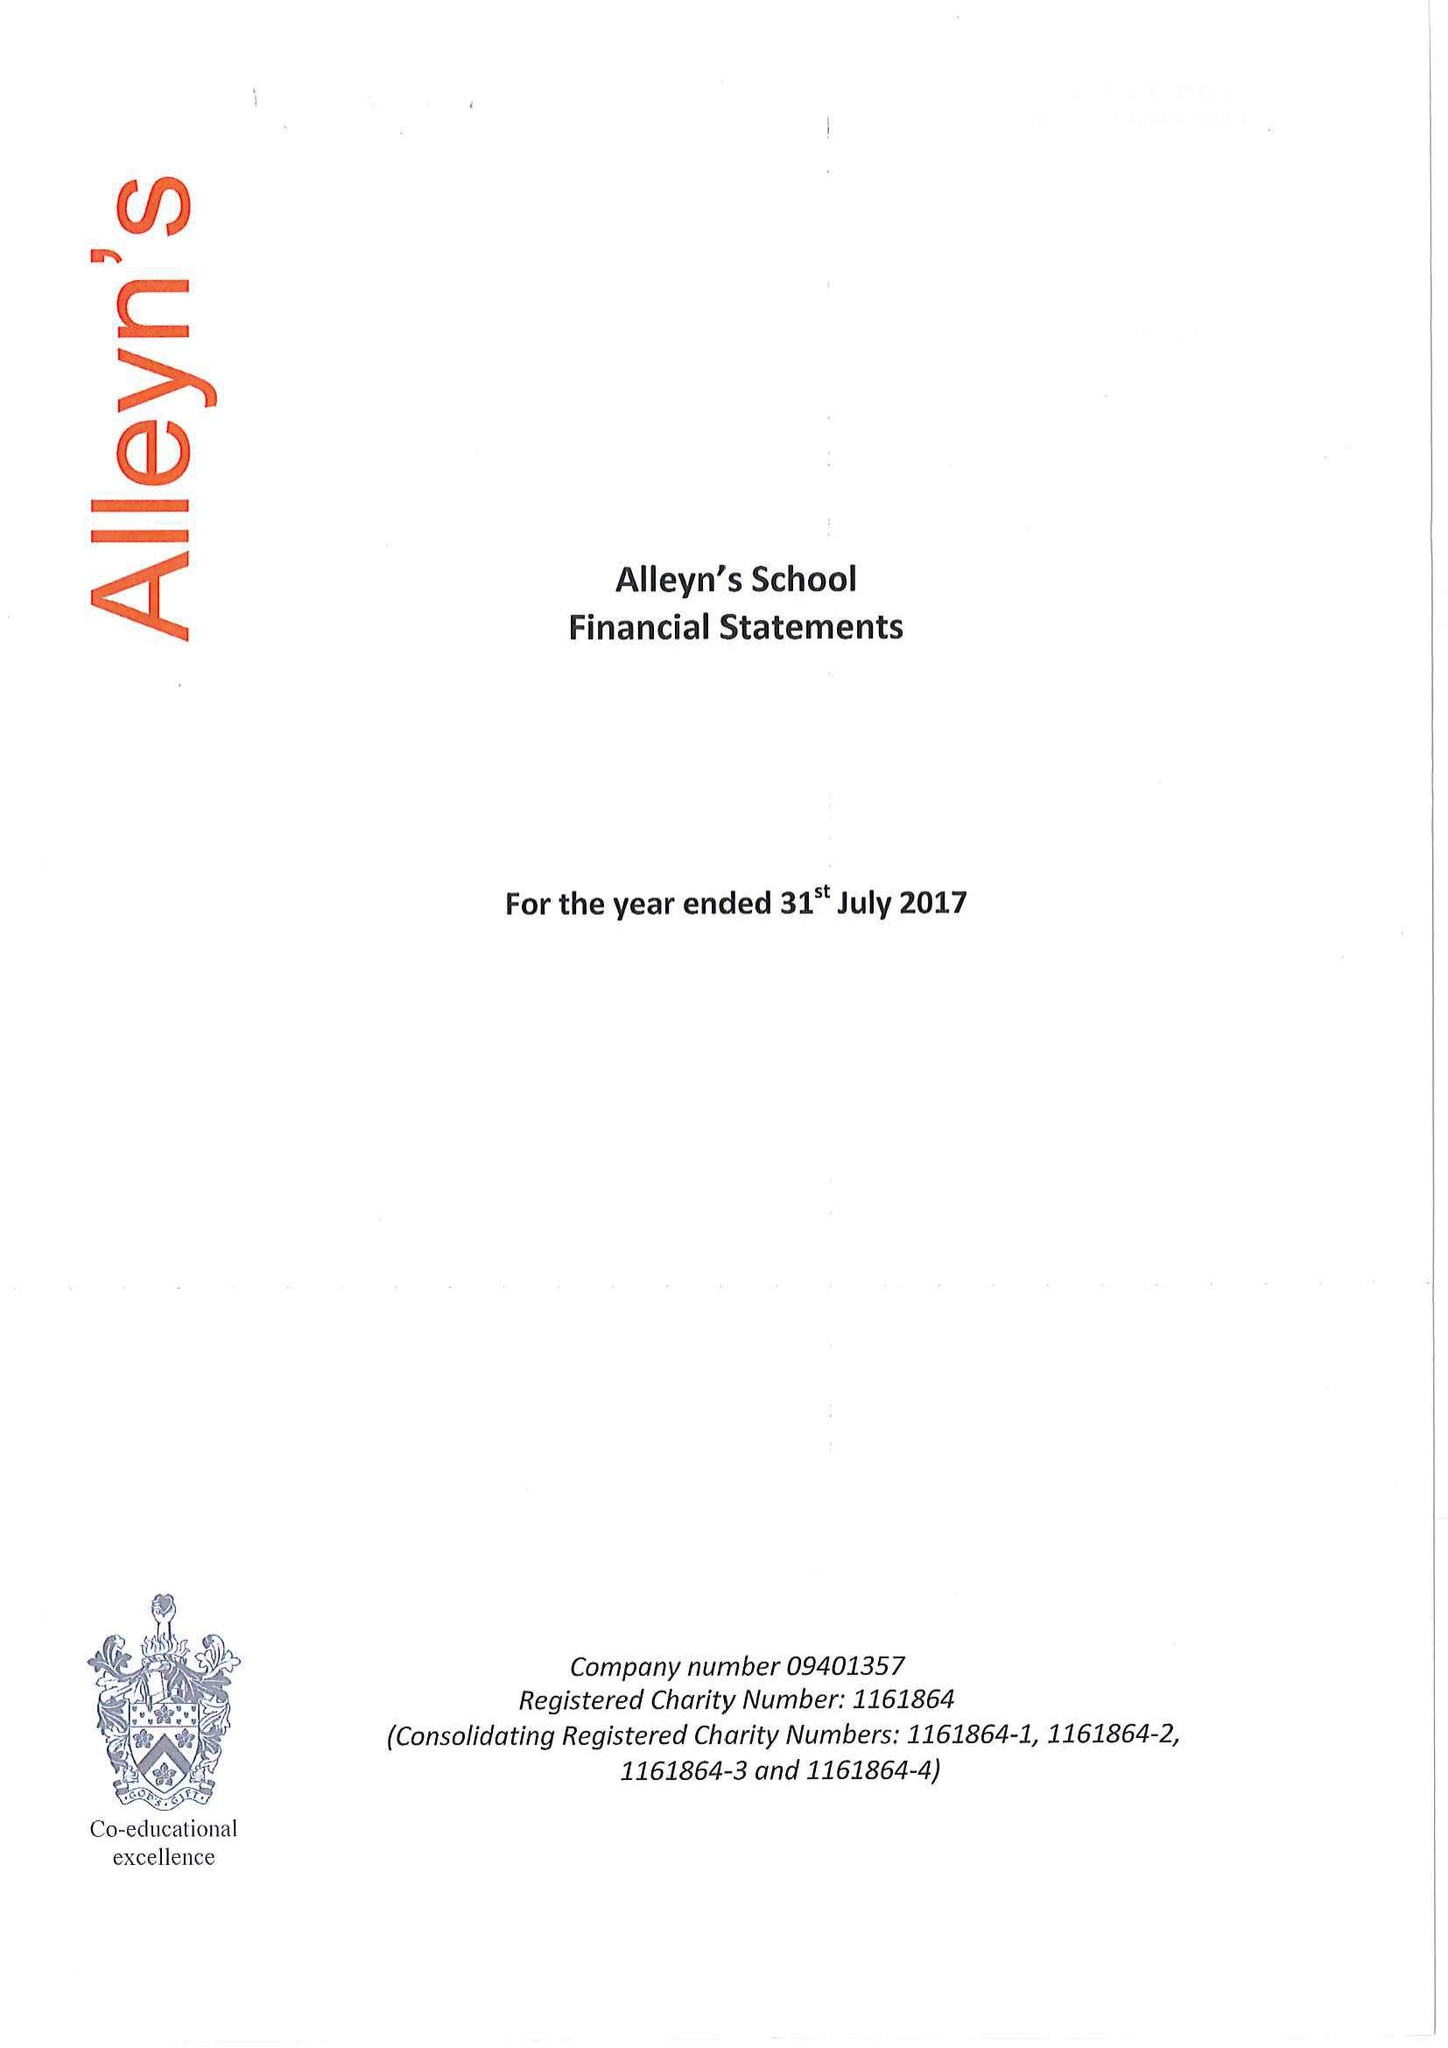What is the value for the charity_number?
Answer the question using a single word or phrase. 1161864 